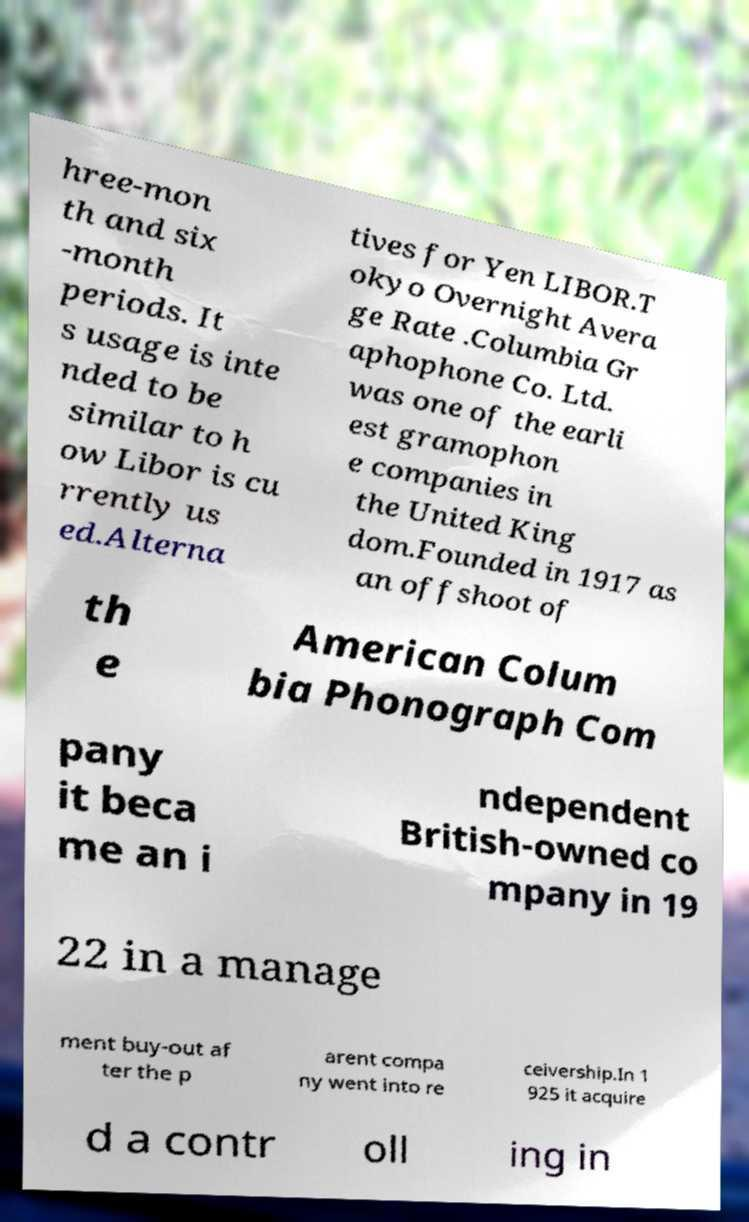Please identify and transcribe the text found in this image. hree-mon th and six -month periods. It s usage is inte nded to be similar to h ow Libor is cu rrently us ed.Alterna tives for Yen LIBOR.T okyo Overnight Avera ge Rate .Columbia Gr aphophone Co. Ltd. was one of the earli est gramophon e companies in the United King dom.Founded in 1917 as an offshoot of th e American Colum bia Phonograph Com pany it beca me an i ndependent British-owned co mpany in 19 22 in a manage ment buy-out af ter the p arent compa ny went into re ceivership.In 1 925 it acquire d a contr oll ing in 